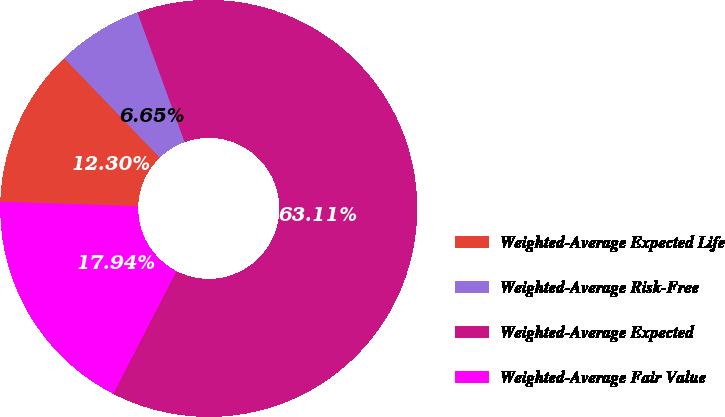Convert chart. <chart><loc_0><loc_0><loc_500><loc_500><pie_chart><fcel>Weighted-Average Expected Life<fcel>Weighted-Average Risk-Free<fcel>Weighted-Average Expected<fcel>Weighted-Average Fair Value<nl><fcel>12.3%<fcel>6.65%<fcel>63.11%<fcel>17.94%<nl></chart> 